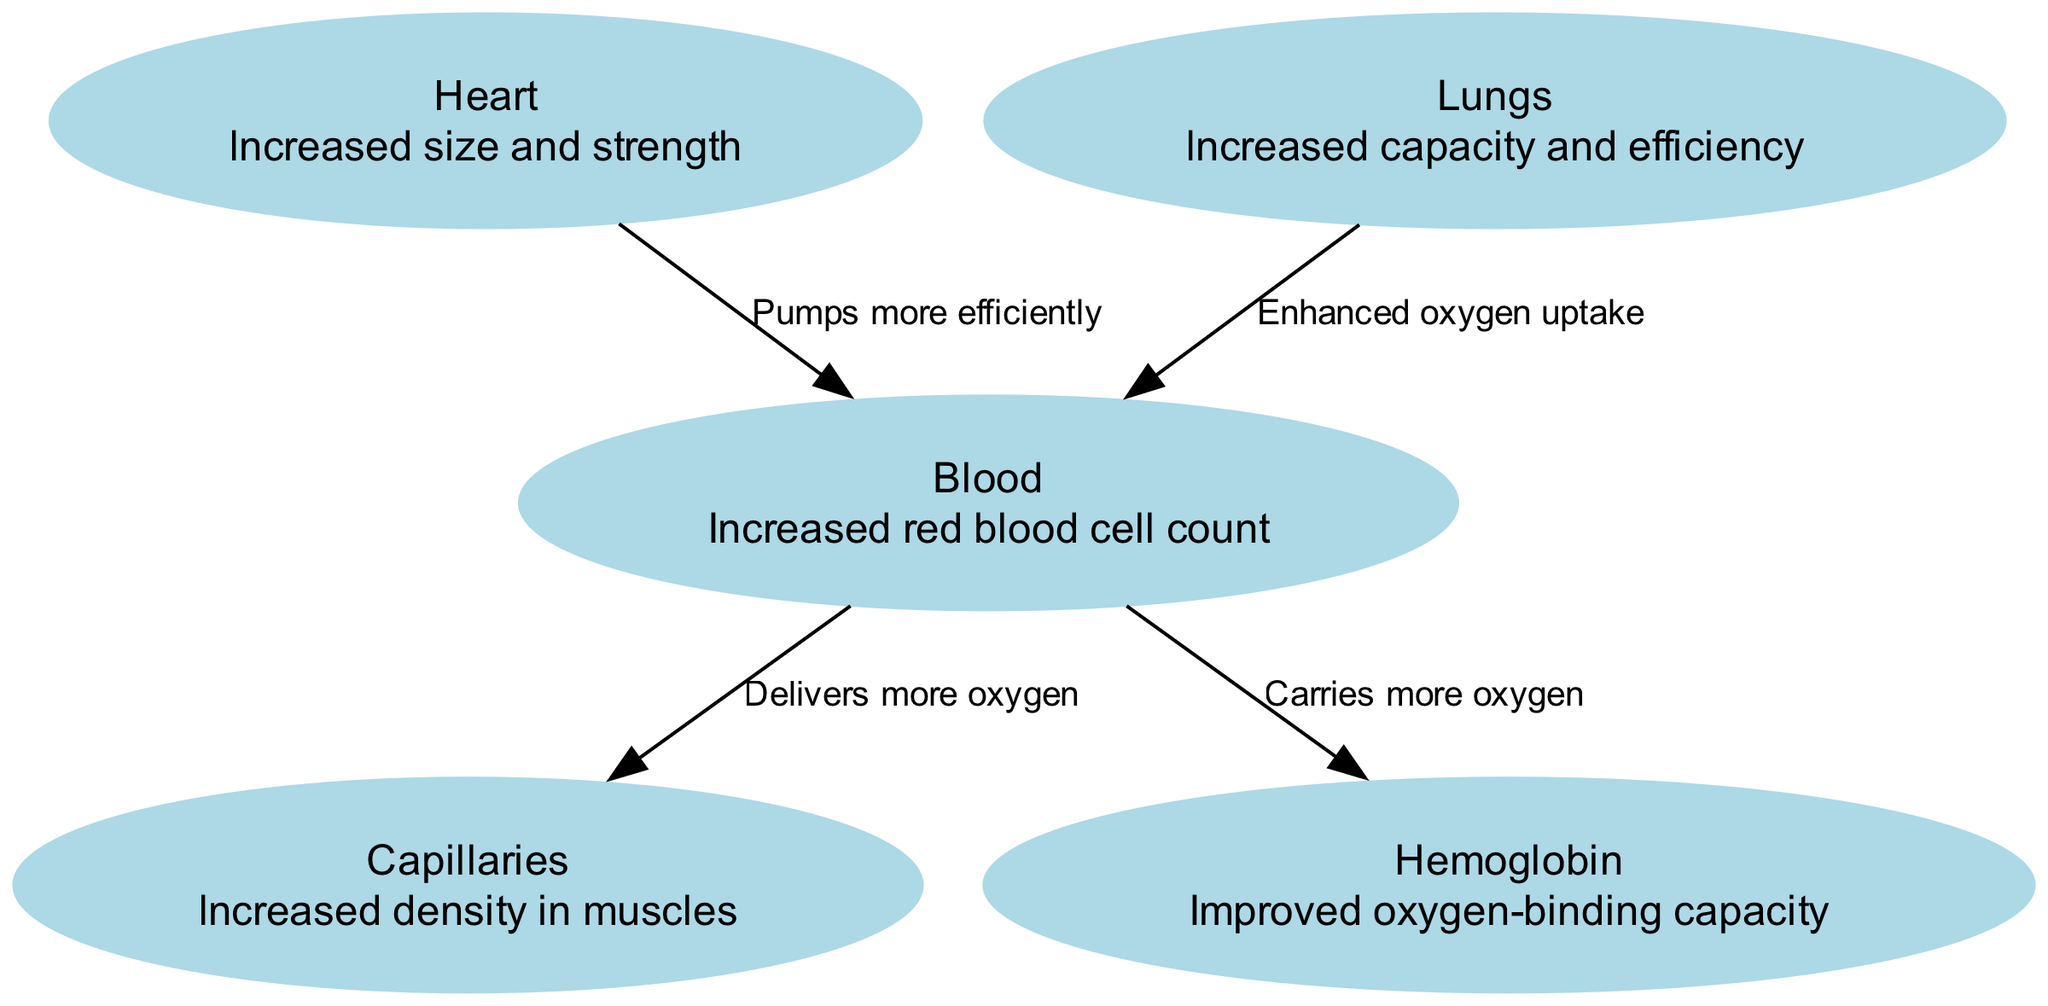What is the label of the node representing the heart? The diagram shows a node labeled "Heart," which indicates the main organ responsible for pumping blood. The description provided explains its adaptation as "Increased size and strength."
Answer: Heart What is the relationship between the lungs and blood? The edge between the lungs and blood indicates the flow of oxygen, specifically stating "Enhanced oxygen uptake." This implies that the lungs improve the quality of blood through better oxygen absorption.
Answer: Enhanced oxygen uptake How many nodes are present in the diagram? The diagram includes five distinct nodes that represent different components of the cardiovascular system adapted for high-altitude hiking: heart, lungs, blood, capillaries, and hemoglobin.
Answer: 5 Which node has the highest red blood cell adaptation? The node labeled "Blood" explicitly mentions "Increased red blood cell count." This indicates that blood is adapted to manage oxygen more effectively in high-altitude conditions.
Answer: Increased red blood cell count What does the capillaries node indicate about muscle adaptation? The "Capillaries" node states "Increased density in muscles," showing that high-altitude adaptation involves greater capillary networks in muscle tissue to improve oxygen delivery during hikes.
Answer: Increased density in muscles What effect does the heart have on blood according to the diagram? The edge from the heart to blood mentions that the heart "Pumps more efficiently," indicating that an adaptation of the heart at high altitudes leads to improved blood circulation.
Answer: Pumps more efficiently Which component is responsible for carrying more oxygen as per the diagram? The "Blood" node emphasizes that it "Carries more oxygen" due to adaptations related to higher altitude, combining with increases in red blood cell count and hemoglobin properties.
Answer: Carries more oxygen How do lungs impact the overall oxygen supply to blood? The connection from lungs to blood emphasizes "Enhanced oxygen uptake," which suggests that lungs play a critical role in boosting the overall oxygen supply the blood can transport throughout the body.
Answer: Enhanced oxygen uptake What advantage does hemoglobin provide in high-altitude hiking? The "Hemoglobin" node states "Improved oxygen-binding capacity," signifying that it allows blood to hold and transport greater amounts of oxygen, crucial for sustaining energy at high altitudes.
Answer: Improved oxygen-binding capacity 